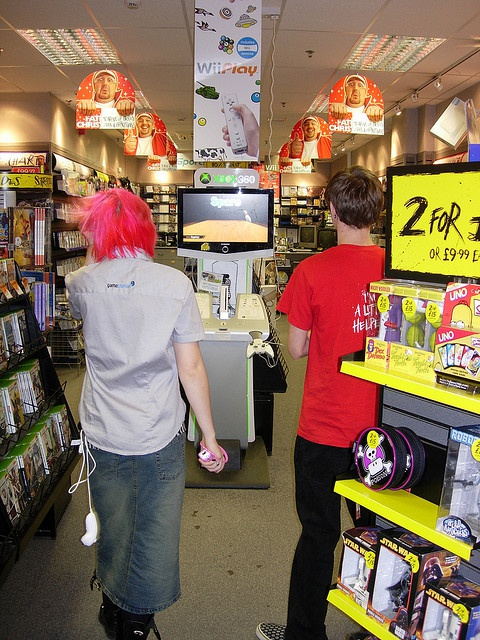Describe the objects in this image and their specific colors. I can see people in brown, lightgray, gray, darkgray, and black tones, people in brown, black, and maroon tones, tv in brown, khaki, black, lightgray, and darkgray tones, tv in brown, black, maroon, darkgreen, and gray tones, and remote in brown, lightgray, darkgray, gray, and beige tones in this image. 